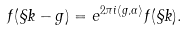<formula> <loc_0><loc_0><loc_500><loc_500>f ( \S k - g ) = e ^ { 2 \pi i \langle g , \alpha \rangle } f ( \S k ) .</formula> 